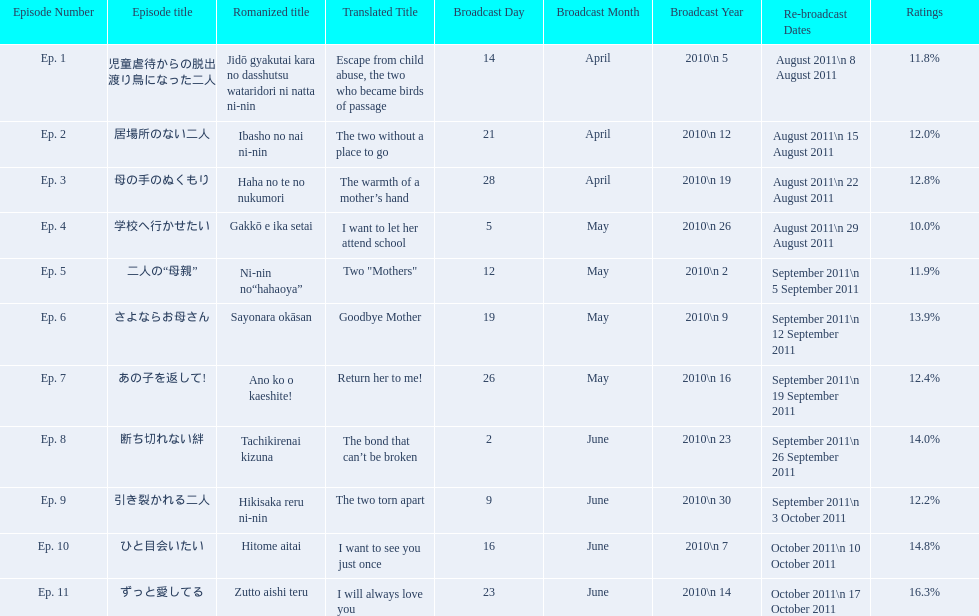What are all of the episode numbers? Ep. 1, Ep. 2, Ep. 3, Ep. 4, Ep. 5, Ep. 6, Ep. 7, Ep. 8, Ep. 9, Ep. 10, Ep. 11. And their titles? 児童虐待からの脱出 渡り鳥になった二人, 居場所のない二人, 母の手のぬくもり, 学校へ行かせたい, 二人の“母親”, さよならお母さん, あの子を返して!, 断ち切れない絆, 引き裂かれる二人, ひと目会いたい, ずっと愛してる. What about their translated names? Escape from child abuse, the two who became birds of passage, The two without a place to go, The warmth of a mother’s hand, I want to let her attend school, Two "Mothers", Goodbye Mother, Return her to me!, The bond that can’t be broken, The two torn apart, I want to see you just once, I will always love you. Which episode number's title translated to i want to let her attend school? Ep. 4. 